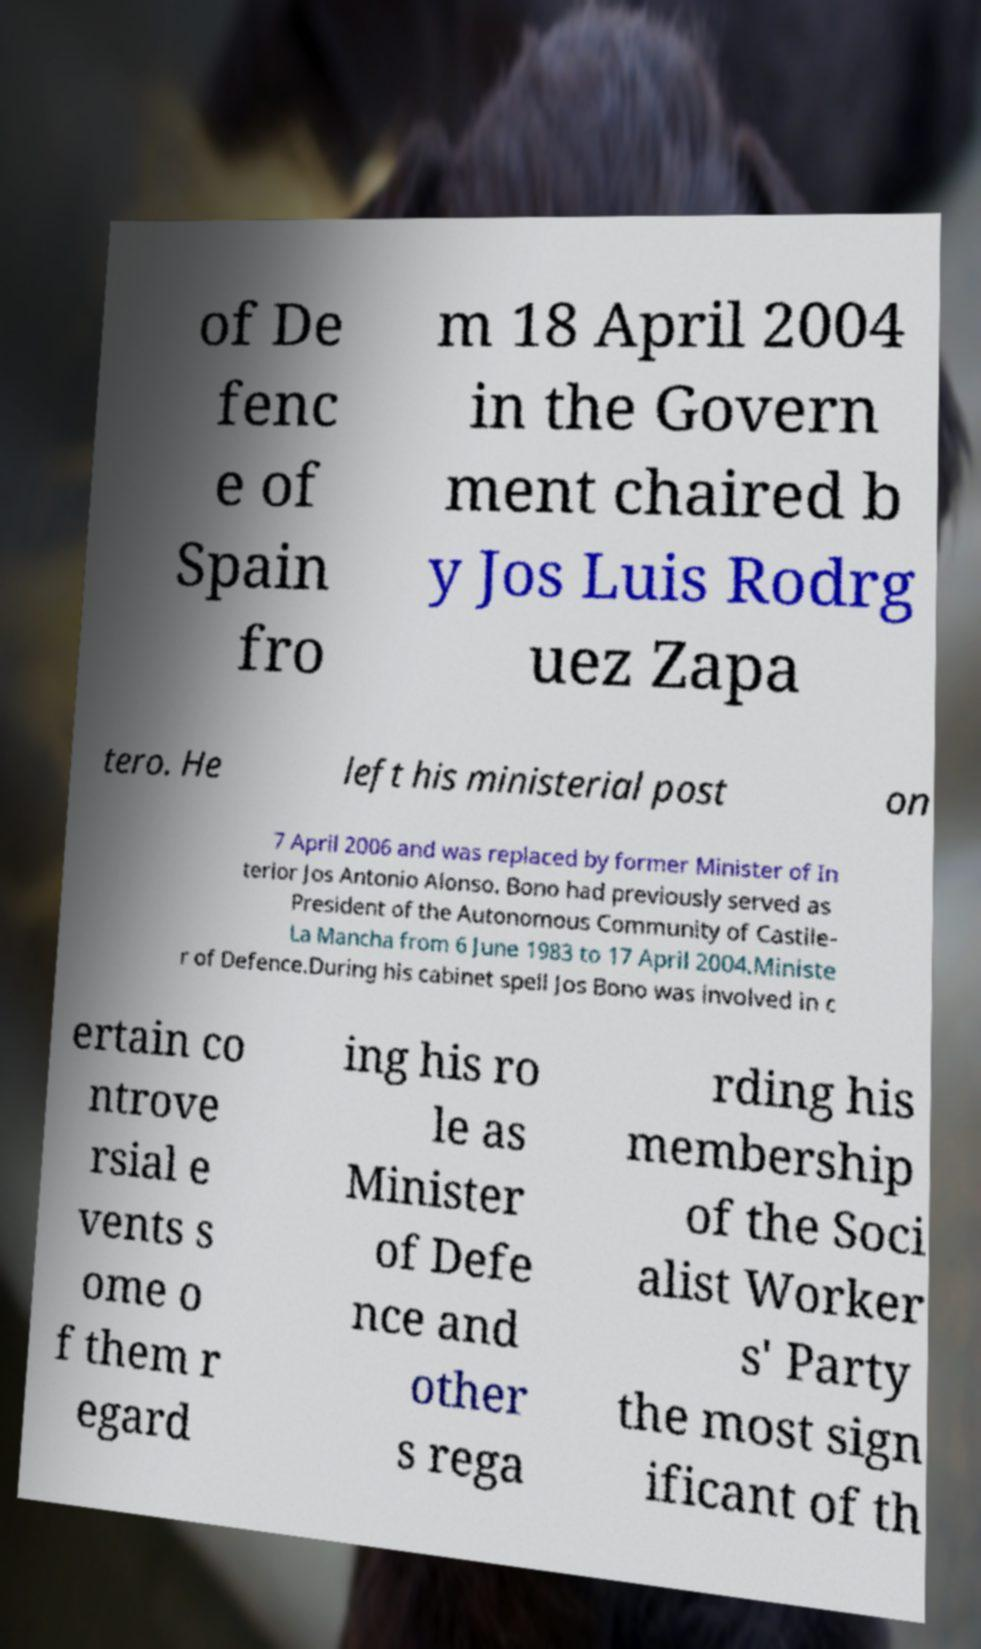I need the written content from this picture converted into text. Can you do that? of De fenc e of Spain fro m 18 April 2004 in the Govern ment chaired b y Jos Luis Rodrg uez Zapa tero. He left his ministerial post on 7 April 2006 and was replaced by former Minister of In terior Jos Antonio Alonso. Bono had previously served as President of the Autonomous Community of Castile- La Mancha from 6 June 1983 to 17 April 2004.Ministe r of Defence.During his cabinet spell Jos Bono was involved in c ertain co ntrove rsial e vents s ome o f them r egard ing his ro le as Minister of Defe nce and other s rega rding his membership of the Soci alist Worker s' Party the most sign ificant of th 